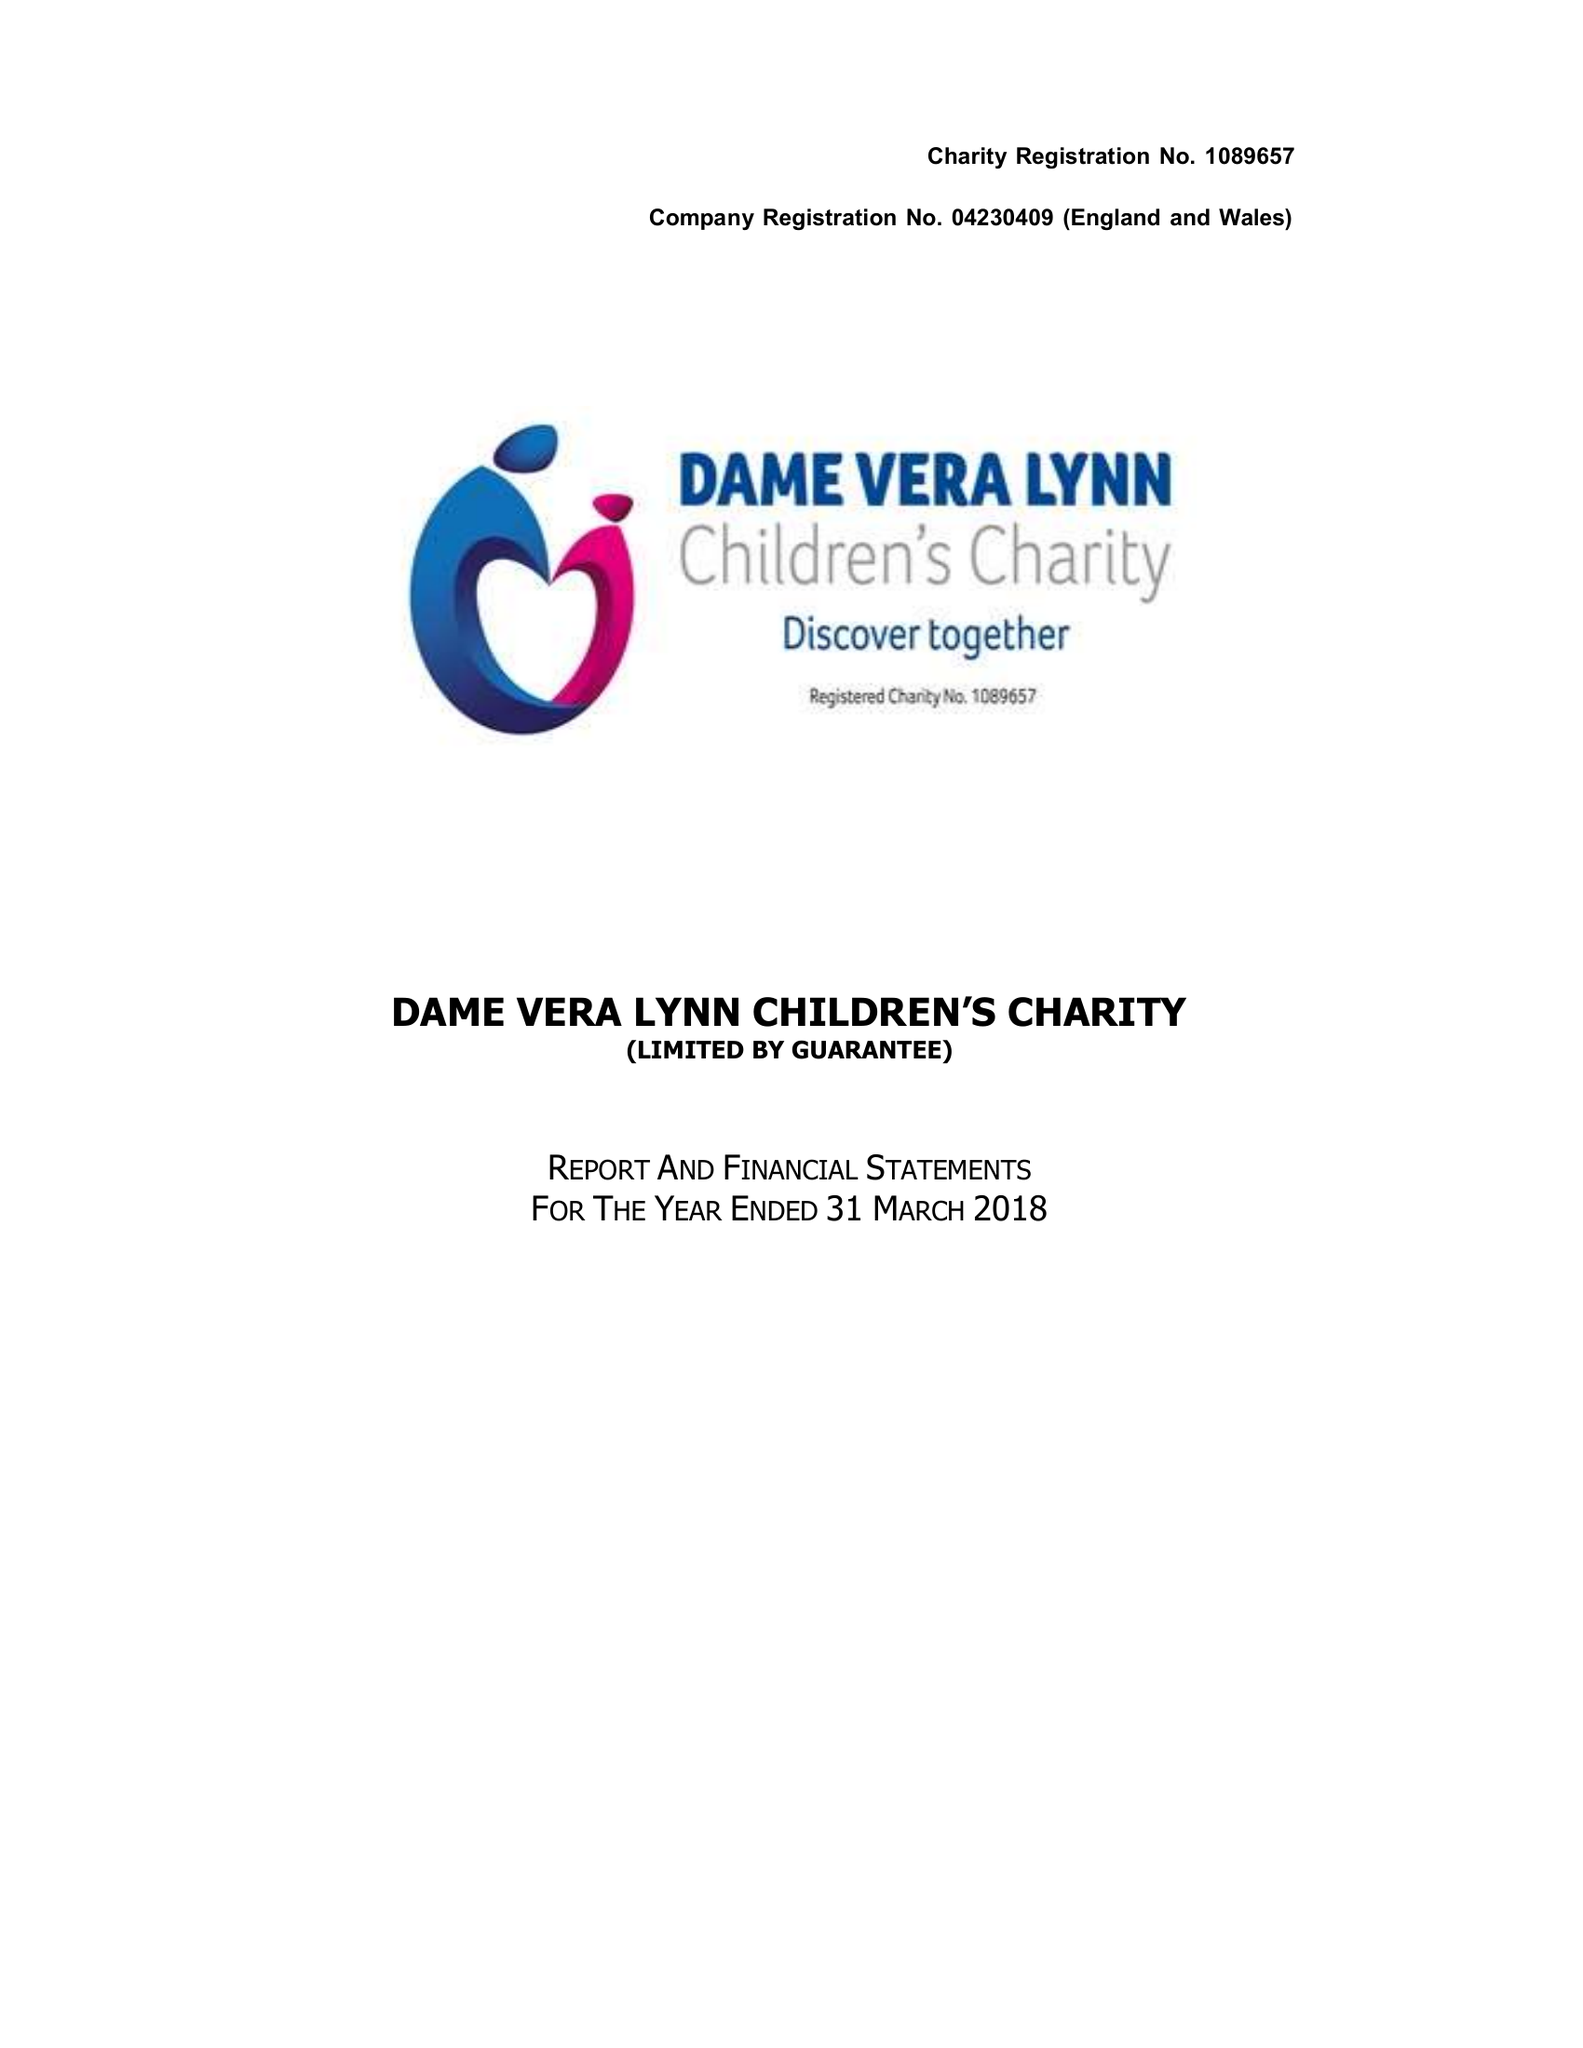What is the value for the charity_name?
Answer the question using a single word or phrase. Dame Vera Lynn Children's Charity 